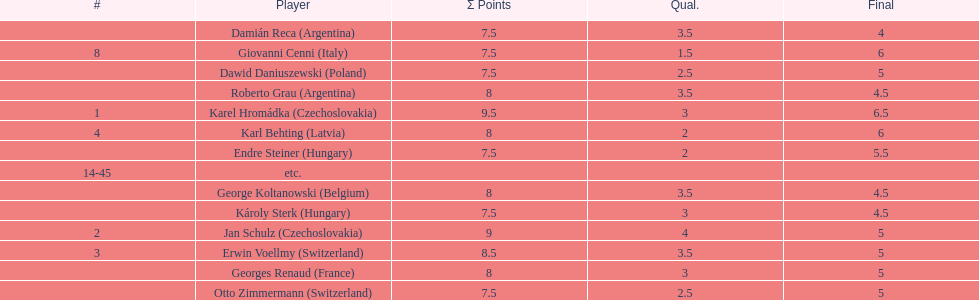Who was the top scorer from switzerland? Erwin Voellmy. 